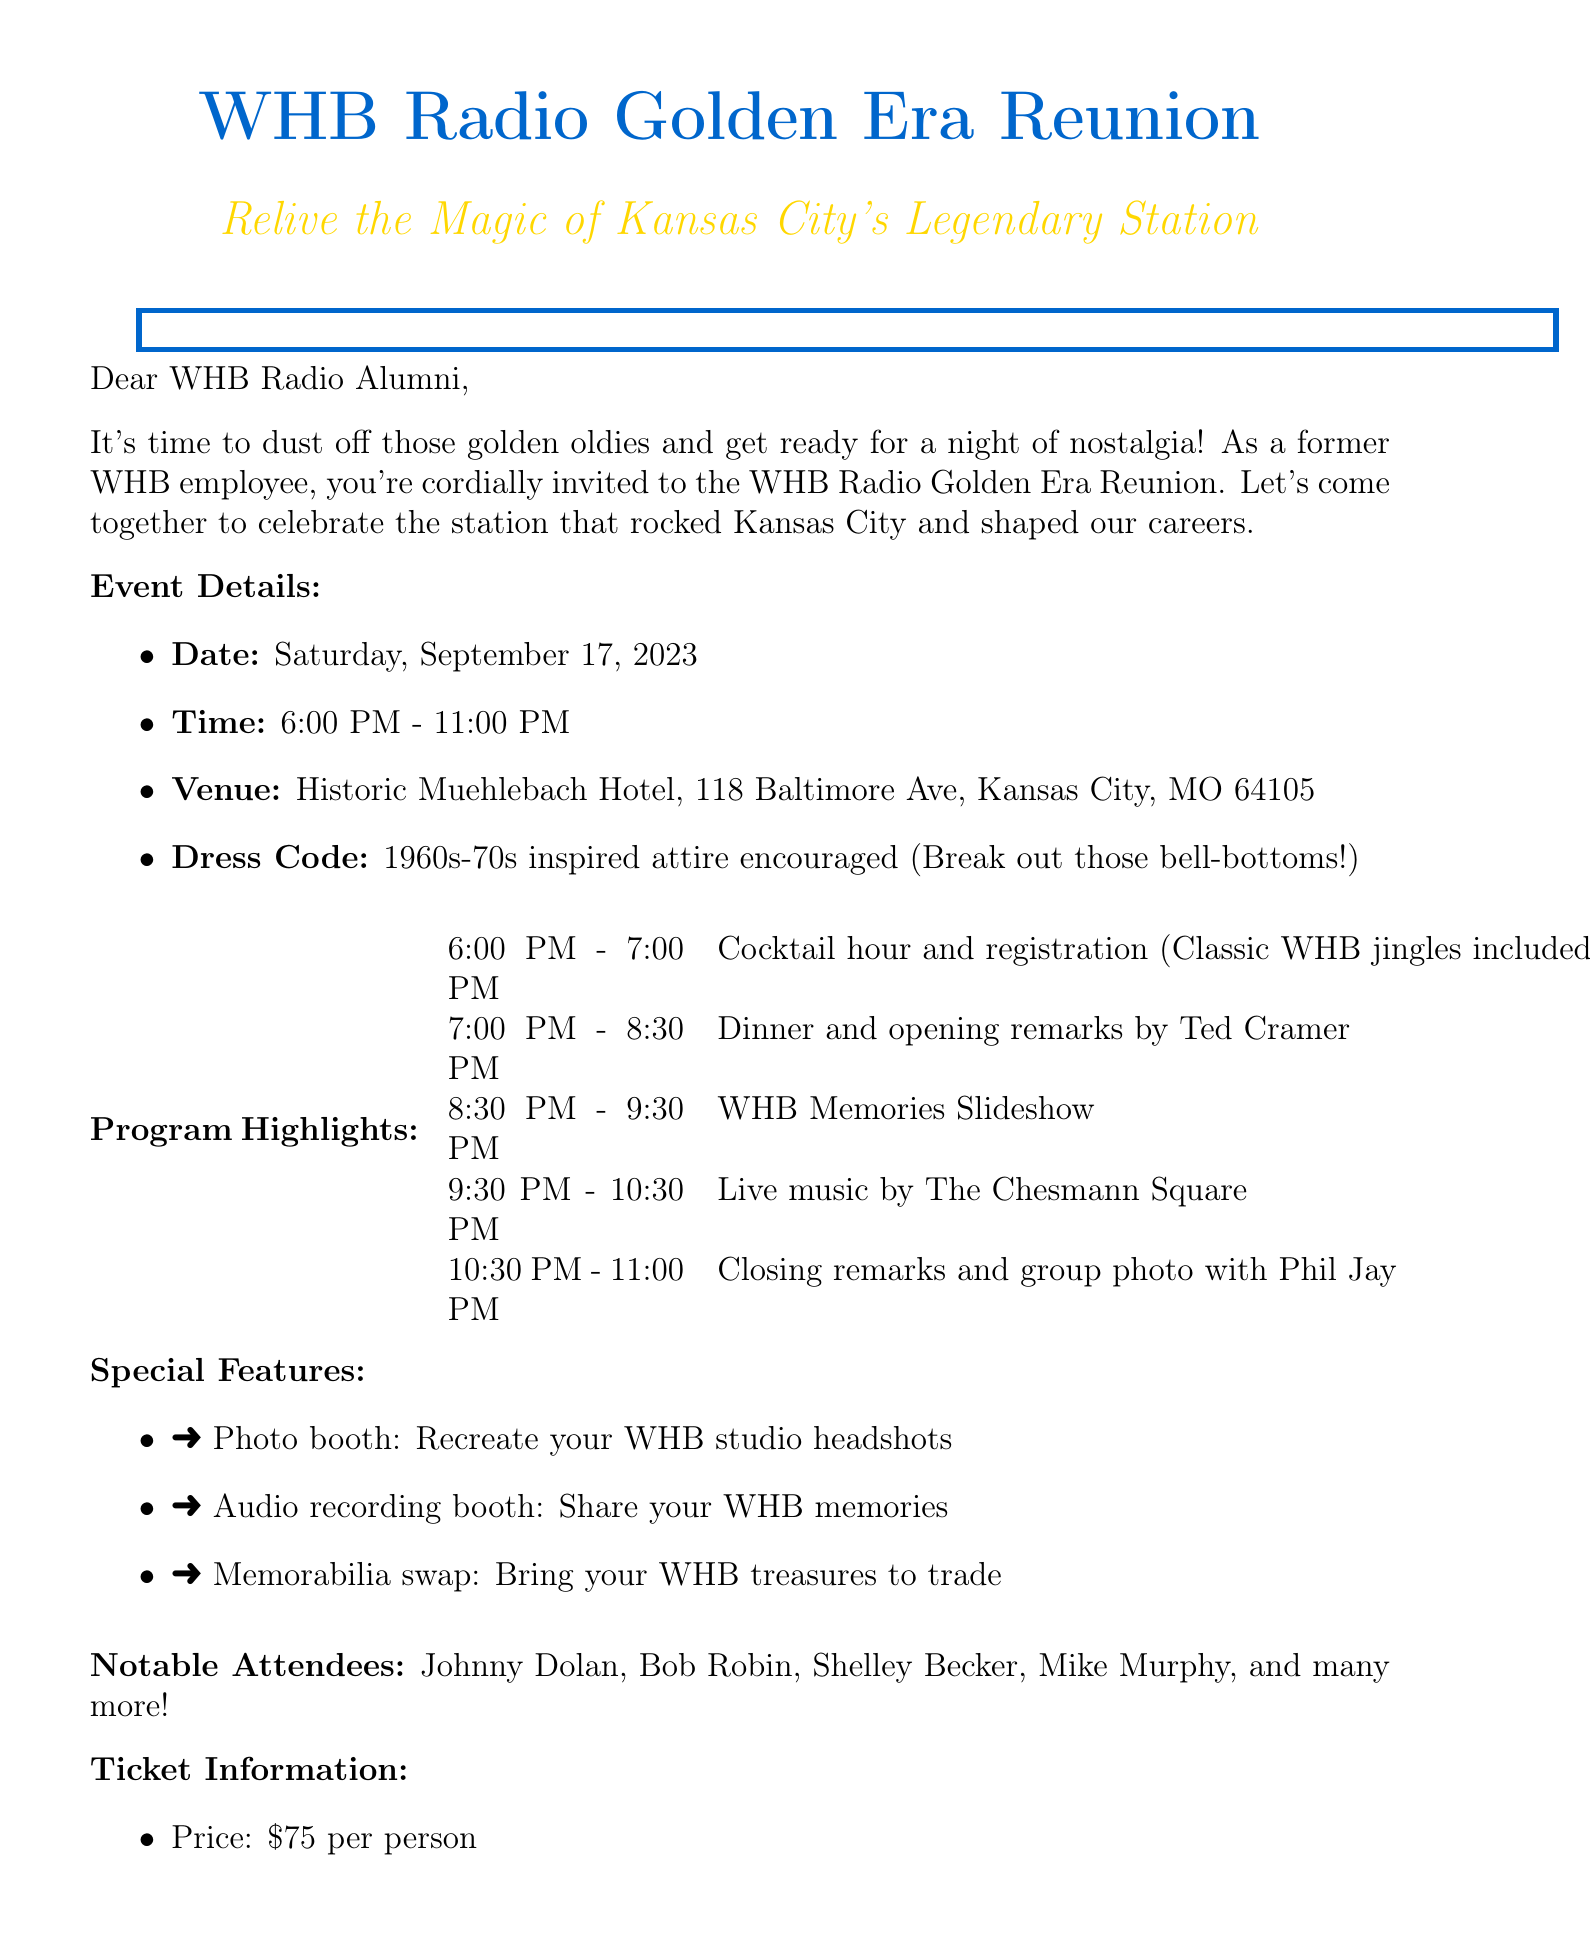What date is the reunion? The reunion date is specified in the event details section of the document.
Answer: Saturday, September 17, 2023 What is the dress code for the event? The dress code is mentioned in the event details section.
Answer: 1960s-70s inspired attire encouraged Who is giving the opening remarks? The person giving the opening remarks is noted in the program schedule.
Answer: Ted Cramer What is the price of the ticket? The ticket price is listed under ticket information.
Answer: $75 per person What is included in the ticket? The ticket information section outlines the items included in the ticket price.
Answer: Dinner, open bar, commemorative WHB Radio reunion pin, digital download of event photos and audio memories What time does the cocktail hour start? The start time for the cocktail hour is detailed in the program schedule.
Answer: 6:00 PM What special feature allows guests to record memories? The special feature for recording memories is mentioned in the special features section.
Answer: Audio recording booth How many notable attendees are listed? The list of notable attendees provides a count in the document.
Answer: Four What is the RSVP deadline? The RSVP deadline is stated in the RSVP details section.
Answer: August 15, 2023 